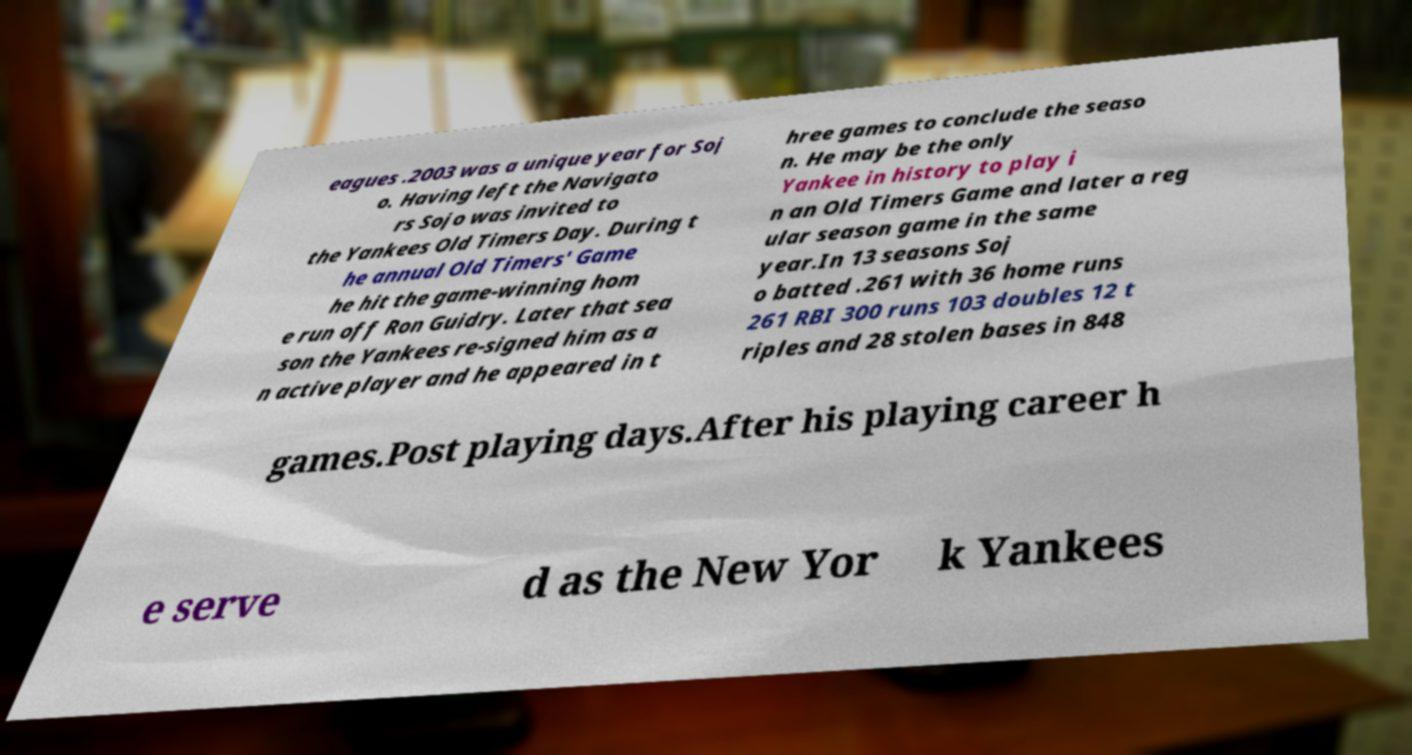Please identify and transcribe the text found in this image. eagues .2003 was a unique year for Soj o. Having left the Navigato rs Sojo was invited to the Yankees Old Timers Day. During t he annual Old Timers' Game he hit the game-winning hom e run off Ron Guidry. Later that sea son the Yankees re-signed him as a n active player and he appeared in t hree games to conclude the seaso n. He may be the only Yankee in history to play i n an Old Timers Game and later a reg ular season game in the same year.In 13 seasons Soj o batted .261 with 36 home runs 261 RBI 300 runs 103 doubles 12 t riples and 28 stolen bases in 848 games.Post playing days.After his playing career h e serve d as the New Yor k Yankees 